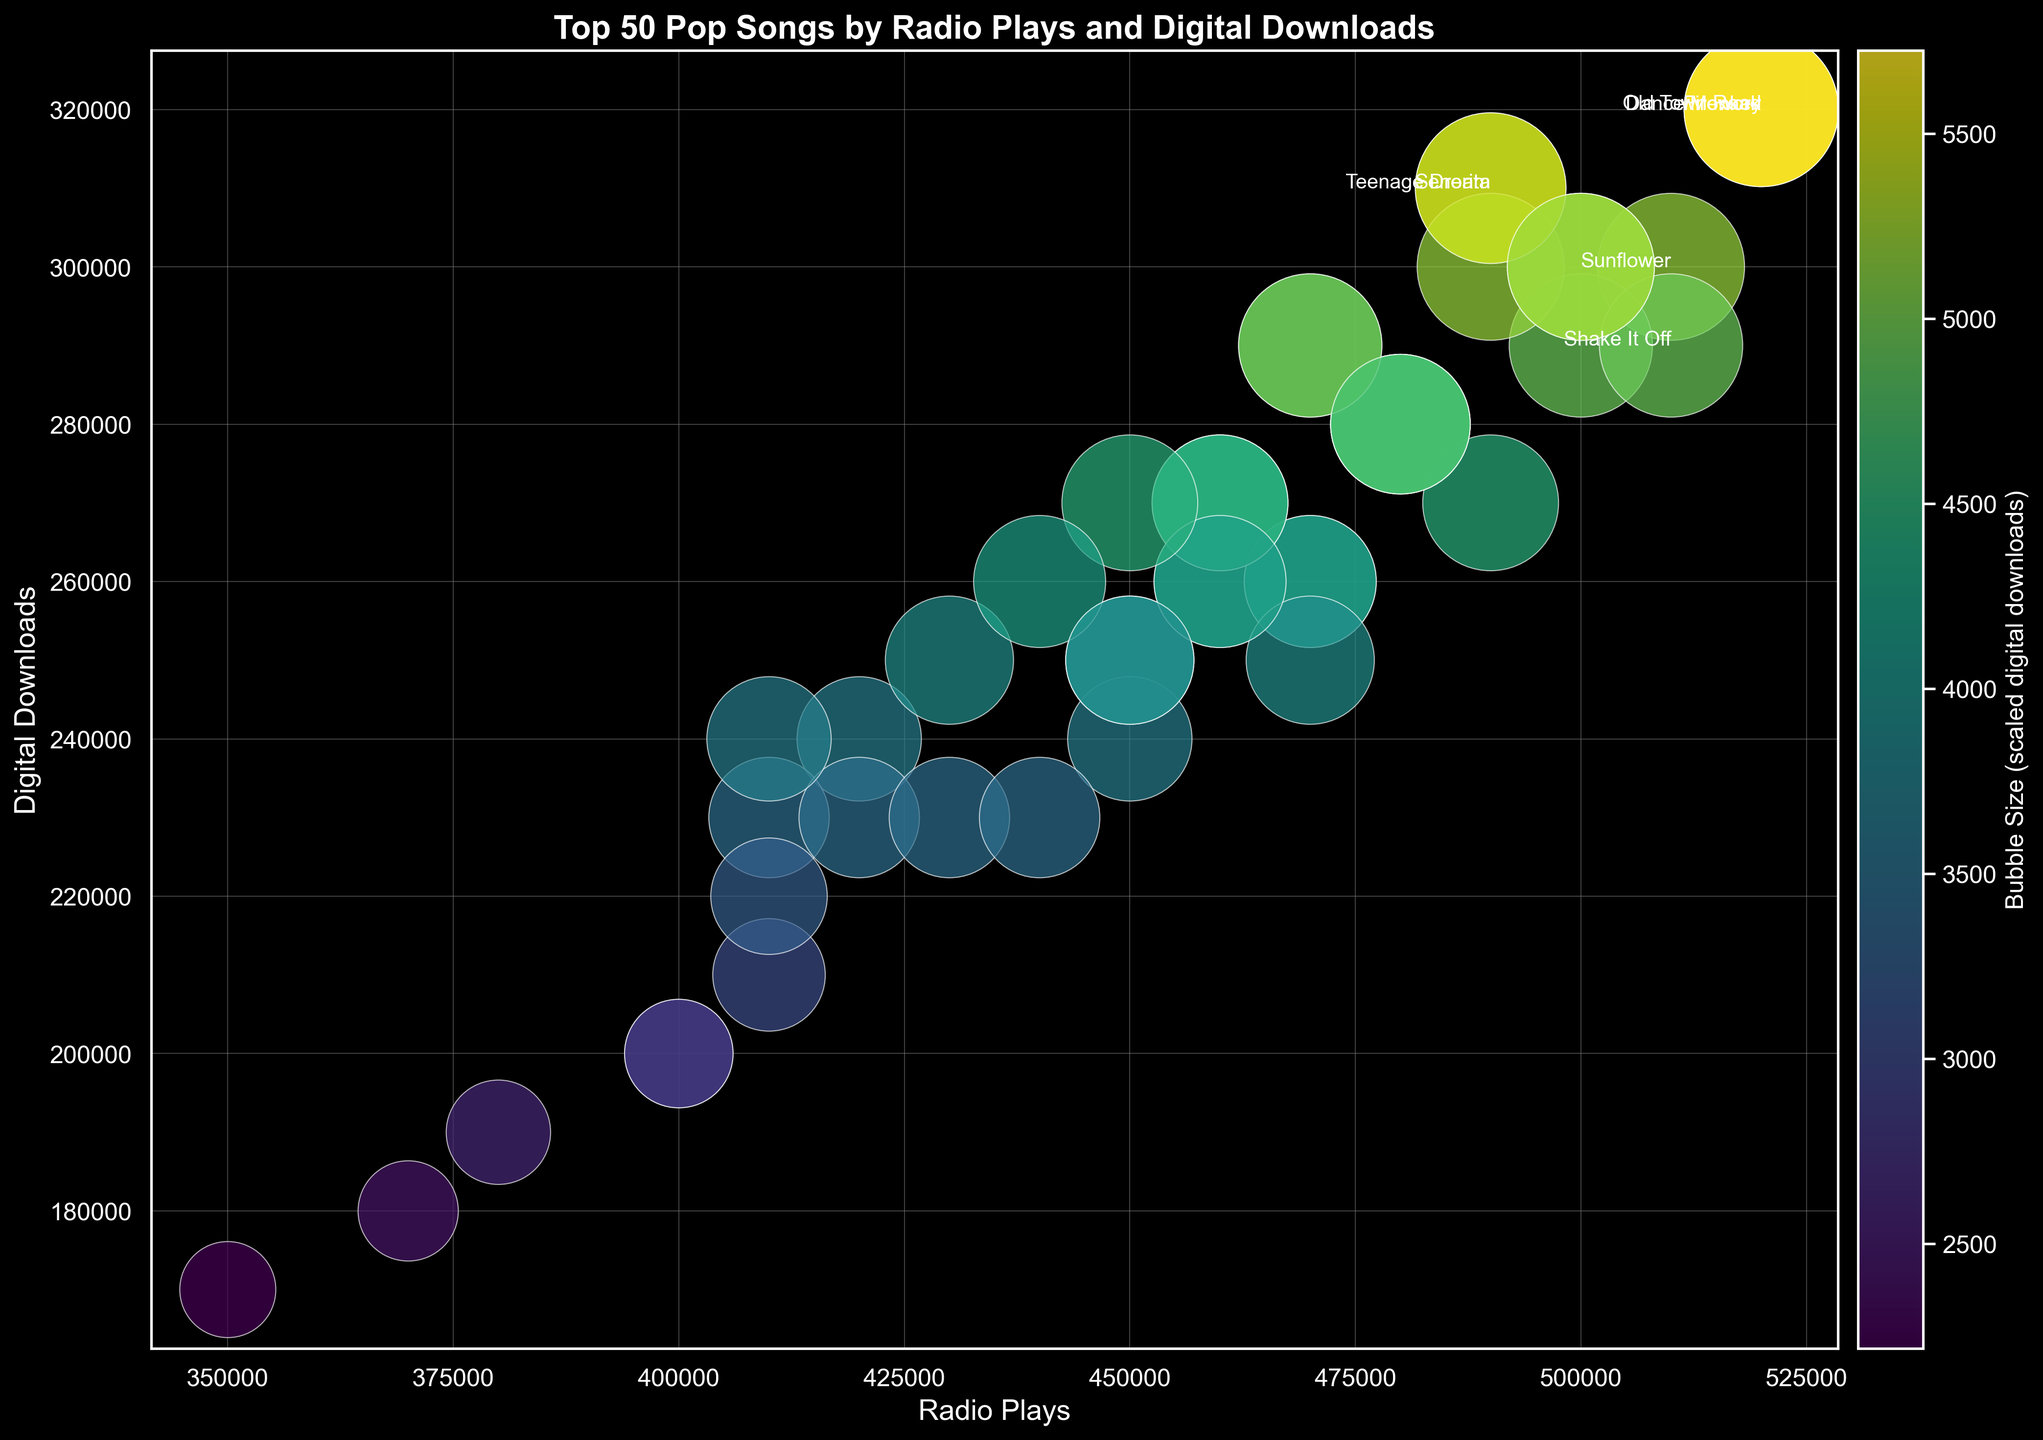Which song has the highest number of radio plays? To find the song with the highest radio plays, identify the data point with the largest value on the x-axis. The song at this point is "Dance Monkey" by Tones and I.
Answer: Dance Monkey by Tones and I Which song has more digital downloads: "Shape Of You" by Ed Sheeran or "Blinding Lights" by The Weeknd? Compare the digital downloads of the two songs by looking at their positions on the y-axis. "Shape Of You" has 260,000 downloads, while "Blinding Lights" has 250,000 downloads.
Answer: Shape Of You by Ed Sheeran What is the average radio plays for the songs by Dua Lipa? Calculate the average by summing the radio plays for all Dua Lipa songs and dividing by the number of her songs. The songs and their plays are "Levitating" (410,000), "Don't Start Now" (450,000), and "Break My Heart" (400,000). So, (410,000 + 450,000 + 400,000) / 3 = 420,000.
Answer: 420,000 Which song has a larger bubble size, "Uptown Funk" by Mark Ronson ft. Bruno Mars or "Bad Guy" by Billie Eilish? Compare the sizes of the bubbles representing the two songs. "Bad Guy" has a slightly larger bubble size correlating to higher digital downloads (280,000) compared to "Uptown Funk" (300,000).
Answer: Uptown Funk by Mark Ronson ft. Bruno Mars Are there any songs that have more than 500,000 radio plays and 300,000 digital downloads? Check the data points that exceed both thresholds on the x and y axes. The songs "Old Town Road", "Dance Monkey" and "Firework" qualify.
Answer: Old Town Road, Dance Monkey, Firework Is the radio play count for "Just Dance" by Lady Gaga ft. Colby O'Donis greater than that of "Sunflower" by Post Malone & Swae Lee? Compare their positions along the x-axis. "Just Dance" has 500,000 radio plays, while "Sunflower" has 510,000 radio plays.
Answer: No What's the difference in digital downloads between "Rolling in the Deep" by Adele and "Truth Hurts" by Lizzo? Subtract the digital downloads of "Truth Hurts" (260,000) from "Rolling in the Deep" (280,000). 280,000 - 260,000 = 20,000.
Answer: 20,000 How do the bubble colors visually represent the digital downloads? The bubble colors change based on the size of the digital downloads, with a color gradient from darker to brighter. Larger digital downloads are represented by brighter colored bubbles.
Answer: Gradient from dark to bright Which song has more digital downloads: "Perfect" by Ed Sheeran or "Stay" by The Kid LAROI & Justin Bieber? Compare the vertical positions of the data points. "Perfect" has 280,000 downloads, while "Stay" has 260,000 downloads.
Answer: Perfect by Ed Sheeran 